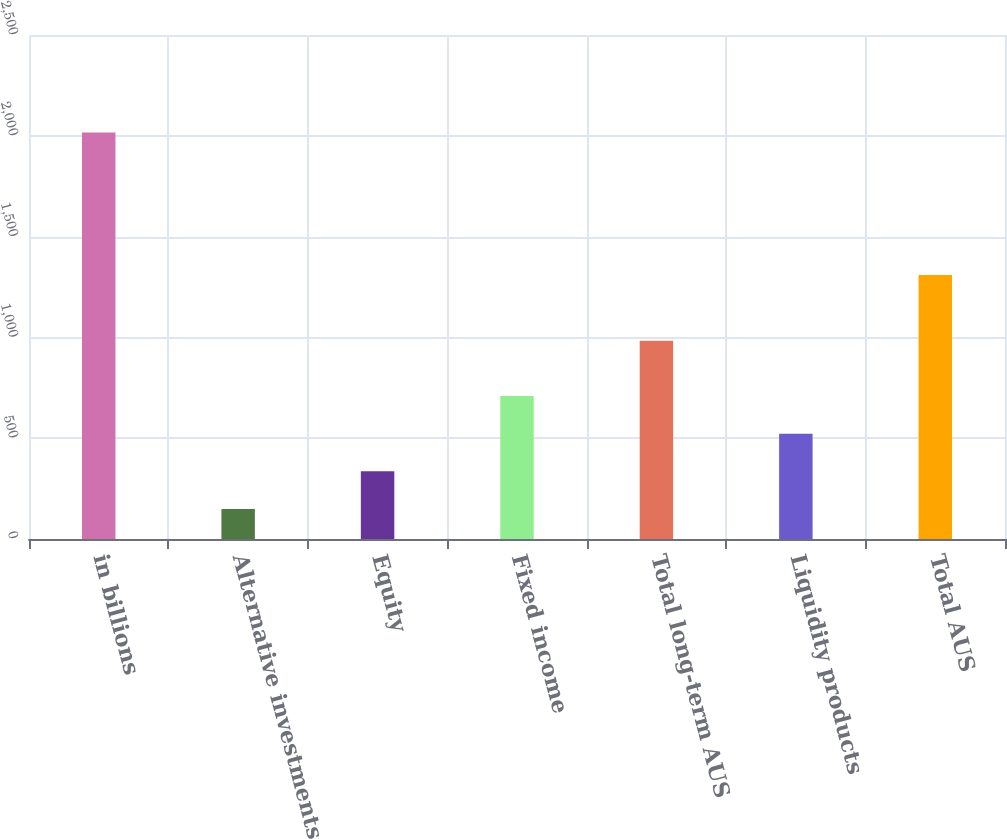Convert chart. <chart><loc_0><loc_0><loc_500><loc_500><bar_chart><fcel>in billions<fcel>Alternative investments<fcel>Equity<fcel>Fixed income<fcel>Total long-term AUS<fcel>Liquidity products<fcel>Total AUS<nl><fcel>2016<fcel>149<fcel>335.7<fcel>709.1<fcel>983<fcel>522.4<fcel>1309<nl></chart> 